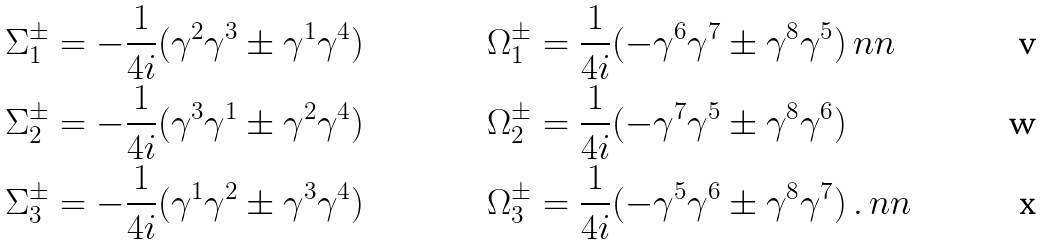<formula> <loc_0><loc_0><loc_500><loc_500>\Sigma _ { 1 } ^ { \pm } & = - \frac { 1 } { 4 i } ( \gamma ^ { 2 } \gamma ^ { 3 } \pm \gamma ^ { 1 } \gamma ^ { 4 } ) & \Omega _ { 1 } ^ { \pm } & = \frac { 1 } { 4 i } ( - \gamma ^ { 6 } \gamma ^ { 7 } \pm \gamma ^ { 8 } \gamma ^ { 5 } ) \ n n \\ \Sigma _ { 2 } ^ { \pm } & = - \frac { 1 } { 4 i } ( \gamma ^ { 3 } \gamma ^ { 1 } \pm \gamma ^ { 2 } \gamma ^ { 4 } ) & \Omega _ { 2 } ^ { \pm } & = \frac { 1 } { 4 i } ( - \gamma ^ { 7 } \gamma ^ { 5 } \pm \gamma ^ { 8 } \gamma ^ { 6 } ) \\ \Sigma _ { 3 } ^ { \pm } & = - \frac { 1 } { 4 i } ( \gamma ^ { 1 } \gamma ^ { 2 } \pm \gamma ^ { 3 } \gamma ^ { 4 } ) & \Omega _ { 3 } ^ { \pm } & = \frac { 1 } { 4 i } ( - \gamma ^ { 5 } \gamma ^ { 6 } \pm \gamma ^ { 8 } \gamma ^ { 7 } ) \, . \ n n</formula> 